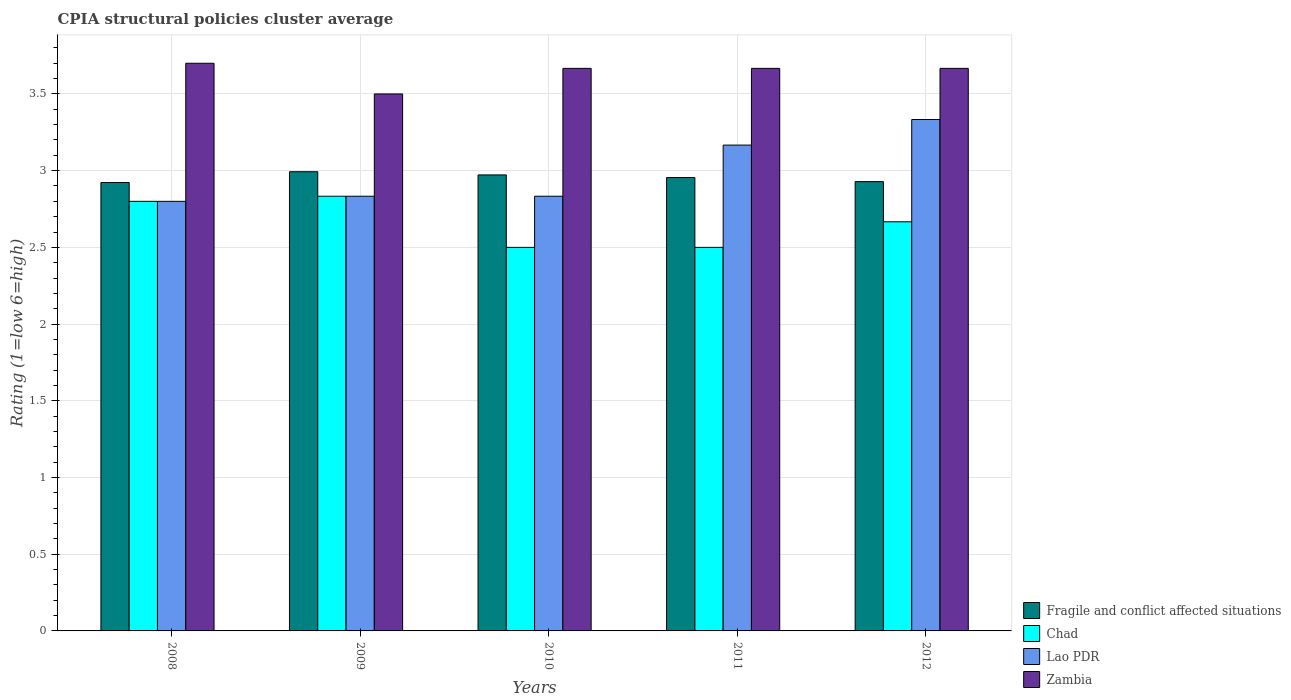How many groups of bars are there?
Make the answer very short. 5. Are the number of bars on each tick of the X-axis equal?
Ensure brevity in your answer.  Yes. What is the label of the 3rd group of bars from the left?
Provide a short and direct response. 2010. Across all years, what is the minimum CPIA rating in Fragile and conflict affected situations?
Ensure brevity in your answer.  2.92. In which year was the CPIA rating in Fragile and conflict affected situations minimum?
Make the answer very short. 2008. What is the total CPIA rating in Zambia in the graph?
Provide a succinct answer. 18.2. What is the difference between the CPIA rating in Lao PDR in 2009 and that in 2010?
Your answer should be compact. 0. What is the difference between the CPIA rating in Lao PDR in 2009 and the CPIA rating in Fragile and conflict affected situations in 2012?
Keep it short and to the point. -0.1. What is the average CPIA rating in Zambia per year?
Give a very brief answer. 3.64. In the year 2009, what is the difference between the CPIA rating in Zambia and CPIA rating in Chad?
Ensure brevity in your answer.  0.67. What is the ratio of the CPIA rating in Zambia in 2008 to that in 2009?
Your response must be concise. 1.06. What is the difference between the highest and the second highest CPIA rating in Fragile and conflict affected situations?
Offer a terse response. 0.02. What is the difference between the highest and the lowest CPIA rating in Zambia?
Provide a succinct answer. 0.2. In how many years, is the CPIA rating in Fragile and conflict affected situations greater than the average CPIA rating in Fragile and conflict affected situations taken over all years?
Ensure brevity in your answer.  3. What does the 3rd bar from the left in 2012 represents?
Your response must be concise. Lao PDR. What does the 1st bar from the right in 2012 represents?
Offer a terse response. Zambia. Is it the case that in every year, the sum of the CPIA rating in Chad and CPIA rating in Zambia is greater than the CPIA rating in Fragile and conflict affected situations?
Make the answer very short. Yes. How many bars are there?
Offer a terse response. 20. Are all the bars in the graph horizontal?
Offer a terse response. No. Does the graph contain any zero values?
Provide a succinct answer. No. Where does the legend appear in the graph?
Provide a short and direct response. Bottom right. How many legend labels are there?
Give a very brief answer. 4. What is the title of the graph?
Provide a succinct answer. CPIA structural policies cluster average. Does "Hong Kong" appear as one of the legend labels in the graph?
Ensure brevity in your answer.  No. What is the label or title of the X-axis?
Your response must be concise. Years. What is the label or title of the Y-axis?
Give a very brief answer. Rating (1=low 6=high). What is the Rating (1=low 6=high) of Fragile and conflict affected situations in 2008?
Your response must be concise. 2.92. What is the Rating (1=low 6=high) in Lao PDR in 2008?
Keep it short and to the point. 2.8. What is the Rating (1=low 6=high) in Zambia in 2008?
Make the answer very short. 3.7. What is the Rating (1=low 6=high) in Fragile and conflict affected situations in 2009?
Your response must be concise. 2.99. What is the Rating (1=low 6=high) of Chad in 2009?
Your response must be concise. 2.83. What is the Rating (1=low 6=high) of Lao PDR in 2009?
Offer a terse response. 2.83. What is the Rating (1=low 6=high) in Fragile and conflict affected situations in 2010?
Your response must be concise. 2.97. What is the Rating (1=low 6=high) in Chad in 2010?
Offer a terse response. 2.5. What is the Rating (1=low 6=high) in Lao PDR in 2010?
Make the answer very short. 2.83. What is the Rating (1=low 6=high) of Zambia in 2010?
Give a very brief answer. 3.67. What is the Rating (1=low 6=high) in Fragile and conflict affected situations in 2011?
Keep it short and to the point. 2.96. What is the Rating (1=low 6=high) in Chad in 2011?
Your answer should be compact. 2.5. What is the Rating (1=low 6=high) of Lao PDR in 2011?
Keep it short and to the point. 3.17. What is the Rating (1=low 6=high) in Zambia in 2011?
Offer a very short reply. 3.67. What is the Rating (1=low 6=high) in Fragile and conflict affected situations in 2012?
Ensure brevity in your answer.  2.93. What is the Rating (1=low 6=high) of Chad in 2012?
Offer a very short reply. 2.67. What is the Rating (1=low 6=high) in Lao PDR in 2012?
Offer a very short reply. 3.33. What is the Rating (1=low 6=high) in Zambia in 2012?
Offer a very short reply. 3.67. Across all years, what is the maximum Rating (1=low 6=high) of Fragile and conflict affected situations?
Provide a short and direct response. 2.99. Across all years, what is the maximum Rating (1=low 6=high) of Chad?
Your answer should be compact. 2.83. Across all years, what is the maximum Rating (1=low 6=high) of Lao PDR?
Offer a very short reply. 3.33. Across all years, what is the minimum Rating (1=low 6=high) in Fragile and conflict affected situations?
Ensure brevity in your answer.  2.92. Across all years, what is the minimum Rating (1=low 6=high) of Lao PDR?
Make the answer very short. 2.8. Across all years, what is the minimum Rating (1=low 6=high) of Zambia?
Provide a succinct answer. 3.5. What is the total Rating (1=low 6=high) of Fragile and conflict affected situations in the graph?
Give a very brief answer. 14.77. What is the total Rating (1=low 6=high) in Lao PDR in the graph?
Give a very brief answer. 14.97. What is the difference between the Rating (1=low 6=high) of Fragile and conflict affected situations in 2008 and that in 2009?
Ensure brevity in your answer.  -0.07. What is the difference between the Rating (1=low 6=high) in Chad in 2008 and that in 2009?
Make the answer very short. -0.03. What is the difference between the Rating (1=low 6=high) of Lao PDR in 2008 and that in 2009?
Ensure brevity in your answer.  -0.03. What is the difference between the Rating (1=low 6=high) of Fragile and conflict affected situations in 2008 and that in 2010?
Keep it short and to the point. -0.05. What is the difference between the Rating (1=low 6=high) in Lao PDR in 2008 and that in 2010?
Your response must be concise. -0.03. What is the difference between the Rating (1=low 6=high) of Fragile and conflict affected situations in 2008 and that in 2011?
Provide a succinct answer. -0.03. What is the difference between the Rating (1=low 6=high) of Chad in 2008 and that in 2011?
Provide a short and direct response. 0.3. What is the difference between the Rating (1=low 6=high) in Lao PDR in 2008 and that in 2011?
Provide a short and direct response. -0.37. What is the difference between the Rating (1=low 6=high) in Fragile and conflict affected situations in 2008 and that in 2012?
Your answer should be very brief. -0.01. What is the difference between the Rating (1=low 6=high) in Chad in 2008 and that in 2012?
Offer a terse response. 0.13. What is the difference between the Rating (1=low 6=high) in Lao PDR in 2008 and that in 2012?
Provide a short and direct response. -0.53. What is the difference between the Rating (1=low 6=high) in Fragile and conflict affected situations in 2009 and that in 2010?
Give a very brief answer. 0.02. What is the difference between the Rating (1=low 6=high) in Zambia in 2009 and that in 2010?
Offer a terse response. -0.17. What is the difference between the Rating (1=low 6=high) in Fragile and conflict affected situations in 2009 and that in 2011?
Make the answer very short. 0.04. What is the difference between the Rating (1=low 6=high) in Fragile and conflict affected situations in 2009 and that in 2012?
Your answer should be compact. 0.06. What is the difference between the Rating (1=low 6=high) in Chad in 2009 and that in 2012?
Offer a very short reply. 0.17. What is the difference between the Rating (1=low 6=high) in Zambia in 2009 and that in 2012?
Provide a succinct answer. -0.17. What is the difference between the Rating (1=low 6=high) of Fragile and conflict affected situations in 2010 and that in 2011?
Your answer should be compact. 0.02. What is the difference between the Rating (1=low 6=high) of Chad in 2010 and that in 2011?
Your answer should be compact. 0. What is the difference between the Rating (1=low 6=high) of Lao PDR in 2010 and that in 2011?
Offer a terse response. -0.33. What is the difference between the Rating (1=low 6=high) in Fragile and conflict affected situations in 2010 and that in 2012?
Keep it short and to the point. 0.04. What is the difference between the Rating (1=low 6=high) in Chad in 2010 and that in 2012?
Offer a terse response. -0.17. What is the difference between the Rating (1=low 6=high) of Zambia in 2010 and that in 2012?
Offer a terse response. 0. What is the difference between the Rating (1=low 6=high) of Fragile and conflict affected situations in 2011 and that in 2012?
Your response must be concise. 0.03. What is the difference between the Rating (1=low 6=high) of Chad in 2011 and that in 2012?
Offer a terse response. -0.17. What is the difference between the Rating (1=low 6=high) of Zambia in 2011 and that in 2012?
Offer a very short reply. 0. What is the difference between the Rating (1=low 6=high) in Fragile and conflict affected situations in 2008 and the Rating (1=low 6=high) in Chad in 2009?
Your answer should be very brief. 0.09. What is the difference between the Rating (1=low 6=high) in Fragile and conflict affected situations in 2008 and the Rating (1=low 6=high) in Lao PDR in 2009?
Give a very brief answer. 0.09. What is the difference between the Rating (1=low 6=high) of Fragile and conflict affected situations in 2008 and the Rating (1=low 6=high) of Zambia in 2009?
Provide a succinct answer. -0.58. What is the difference between the Rating (1=low 6=high) of Chad in 2008 and the Rating (1=low 6=high) of Lao PDR in 2009?
Keep it short and to the point. -0.03. What is the difference between the Rating (1=low 6=high) of Chad in 2008 and the Rating (1=low 6=high) of Zambia in 2009?
Your answer should be compact. -0.7. What is the difference between the Rating (1=low 6=high) of Lao PDR in 2008 and the Rating (1=low 6=high) of Zambia in 2009?
Your answer should be compact. -0.7. What is the difference between the Rating (1=low 6=high) in Fragile and conflict affected situations in 2008 and the Rating (1=low 6=high) in Chad in 2010?
Ensure brevity in your answer.  0.42. What is the difference between the Rating (1=low 6=high) of Fragile and conflict affected situations in 2008 and the Rating (1=low 6=high) of Lao PDR in 2010?
Offer a terse response. 0.09. What is the difference between the Rating (1=low 6=high) in Fragile and conflict affected situations in 2008 and the Rating (1=low 6=high) in Zambia in 2010?
Provide a succinct answer. -0.74. What is the difference between the Rating (1=low 6=high) in Chad in 2008 and the Rating (1=low 6=high) in Lao PDR in 2010?
Make the answer very short. -0.03. What is the difference between the Rating (1=low 6=high) in Chad in 2008 and the Rating (1=low 6=high) in Zambia in 2010?
Keep it short and to the point. -0.87. What is the difference between the Rating (1=low 6=high) in Lao PDR in 2008 and the Rating (1=low 6=high) in Zambia in 2010?
Provide a succinct answer. -0.87. What is the difference between the Rating (1=low 6=high) of Fragile and conflict affected situations in 2008 and the Rating (1=low 6=high) of Chad in 2011?
Ensure brevity in your answer.  0.42. What is the difference between the Rating (1=low 6=high) of Fragile and conflict affected situations in 2008 and the Rating (1=low 6=high) of Lao PDR in 2011?
Ensure brevity in your answer.  -0.24. What is the difference between the Rating (1=low 6=high) in Fragile and conflict affected situations in 2008 and the Rating (1=low 6=high) in Zambia in 2011?
Offer a very short reply. -0.74. What is the difference between the Rating (1=low 6=high) in Chad in 2008 and the Rating (1=low 6=high) in Lao PDR in 2011?
Your answer should be very brief. -0.37. What is the difference between the Rating (1=low 6=high) of Chad in 2008 and the Rating (1=low 6=high) of Zambia in 2011?
Your answer should be compact. -0.87. What is the difference between the Rating (1=low 6=high) of Lao PDR in 2008 and the Rating (1=low 6=high) of Zambia in 2011?
Your answer should be compact. -0.87. What is the difference between the Rating (1=low 6=high) in Fragile and conflict affected situations in 2008 and the Rating (1=low 6=high) in Chad in 2012?
Keep it short and to the point. 0.26. What is the difference between the Rating (1=low 6=high) in Fragile and conflict affected situations in 2008 and the Rating (1=low 6=high) in Lao PDR in 2012?
Provide a short and direct response. -0.41. What is the difference between the Rating (1=low 6=high) in Fragile and conflict affected situations in 2008 and the Rating (1=low 6=high) in Zambia in 2012?
Keep it short and to the point. -0.74. What is the difference between the Rating (1=low 6=high) of Chad in 2008 and the Rating (1=low 6=high) of Lao PDR in 2012?
Provide a short and direct response. -0.53. What is the difference between the Rating (1=low 6=high) in Chad in 2008 and the Rating (1=low 6=high) in Zambia in 2012?
Provide a succinct answer. -0.87. What is the difference between the Rating (1=low 6=high) of Lao PDR in 2008 and the Rating (1=low 6=high) of Zambia in 2012?
Ensure brevity in your answer.  -0.87. What is the difference between the Rating (1=low 6=high) of Fragile and conflict affected situations in 2009 and the Rating (1=low 6=high) of Chad in 2010?
Your response must be concise. 0.49. What is the difference between the Rating (1=low 6=high) of Fragile and conflict affected situations in 2009 and the Rating (1=low 6=high) of Lao PDR in 2010?
Provide a short and direct response. 0.16. What is the difference between the Rating (1=low 6=high) in Fragile and conflict affected situations in 2009 and the Rating (1=low 6=high) in Zambia in 2010?
Offer a terse response. -0.67. What is the difference between the Rating (1=low 6=high) in Lao PDR in 2009 and the Rating (1=low 6=high) in Zambia in 2010?
Provide a succinct answer. -0.83. What is the difference between the Rating (1=low 6=high) in Fragile and conflict affected situations in 2009 and the Rating (1=low 6=high) in Chad in 2011?
Provide a succinct answer. 0.49. What is the difference between the Rating (1=low 6=high) of Fragile and conflict affected situations in 2009 and the Rating (1=low 6=high) of Lao PDR in 2011?
Keep it short and to the point. -0.17. What is the difference between the Rating (1=low 6=high) of Fragile and conflict affected situations in 2009 and the Rating (1=low 6=high) of Zambia in 2011?
Your answer should be compact. -0.67. What is the difference between the Rating (1=low 6=high) in Lao PDR in 2009 and the Rating (1=low 6=high) in Zambia in 2011?
Provide a short and direct response. -0.83. What is the difference between the Rating (1=low 6=high) in Fragile and conflict affected situations in 2009 and the Rating (1=low 6=high) in Chad in 2012?
Offer a terse response. 0.33. What is the difference between the Rating (1=low 6=high) in Fragile and conflict affected situations in 2009 and the Rating (1=low 6=high) in Lao PDR in 2012?
Ensure brevity in your answer.  -0.34. What is the difference between the Rating (1=low 6=high) of Fragile and conflict affected situations in 2009 and the Rating (1=low 6=high) of Zambia in 2012?
Provide a succinct answer. -0.67. What is the difference between the Rating (1=low 6=high) of Chad in 2009 and the Rating (1=low 6=high) of Lao PDR in 2012?
Ensure brevity in your answer.  -0.5. What is the difference between the Rating (1=low 6=high) in Chad in 2009 and the Rating (1=low 6=high) in Zambia in 2012?
Your answer should be compact. -0.83. What is the difference between the Rating (1=low 6=high) of Fragile and conflict affected situations in 2010 and the Rating (1=low 6=high) of Chad in 2011?
Your answer should be compact. 0.47. What is the difference between the Rating (1=low 6=high) of Fragile and conflict affected situations in 2010 and the Rating (1=low 6=high) of Lao PDR in 2011?
Give a very brief answer. -0.19. What is the difference between the Rating (1=low 6=high) in Fragile and conflict affected situations in 2010 and the Rating (1=low 6=high) in Zambia in 2011?
Make the answer very short. -0.69. What is the difference between the Rating (1=low 6=high) in Chad in 2010 and the Rating (1=low 6=high) in Lao PDR in 2011?
Your answer should be very brief. -0.67. What is the difference between the Rating (1=low 6=high) of Chad in 2010 and the Rating (1=low 6=high) of Zambia in 2011?
Provide a succinct answer. -1.17. What is the difference between the Rating (1=low 6=high) in Lao PDR in 2010 and the Rating (1=low 6=high) in Zambia in 2011?
Your answer should be compact. -0.83. What is the difference between the Rating (1=low 6=high) of Fragile and conflict affected situations in 2010 and the Rating (1=low 6=high) of Chad in 2012?
Provide a succinct answer. 0.31. What is the difference between the Rating (1=low 6=high) of Fragile and conflict affected situations in 2010 and the Rating (1=low 6=high) of Lao PDR in 2012?
Give a very brief answer. -0.36. What is the difference between the Rating (1=low 6=high) in Fragile and conflict affected situations in 2010 and the Rating (1=low 6=high) in Zambia in 2012?
Your answer should be very brief. -0.69. What is the difference between the Rating (1=low 6=high) in Chad in 2010 and the Rating (1=low 6=high) in Lao PDR in 2012?
Give a very brief answer. -0.83. What is the difference between the Rating (1=low 6=high) of Chad in 2010 and the Rating (1=low 6=high) of Zambia in 2012?
Your answer should be compact. -1.17. What is the difference between the Rating (1=low 6=high) of Lao PDR in 2010 and the Rating (1=low 6=high) of Zambia in 2012?
Provide a short and direct response. -0.83. What is the difference between the Rating (1=low 6=high) in Fragile and conflict affected situations in 2011 and the Rating (1=low 6=high) in Chad in 2012?
Offer a very short reply. 0.29. What is the difference between the Rating (1=low 6=high) of Fragile and conflict affected situations in 2011 and the Rating (1=low 6=high) of Lao PDR in 2012?
Make the answer very short. -0.38. What is the difference between the Rating (1=low 6=high) of Fragile and conflict affected situations in 2011 and the Rating (1=low 6=high) of Zambia in 2012?
Ensure brevity in your answer.  -0.71. What is the difference between the Rating (1=low 6=high) in Chad in 2011 and the Rating (1=low 6=high) in Zambia in 2012?
Your answer should be compact. -1.17. What is the difference between the Rating (1=low 6=high) in Lao PDR in 2011 and the Rating (1=low 6=high) in Zambia in 2012?
Offer a very short reply. -0.5. What is the average Rating (1=low 6=high) of Fragile and conflict affected situations per year?
Your response must be concise. 2.95. What is the average Rating (1=low 6=high) of Chad per year?
Give a very brief answer. 2.66. What is the average Rating (1=low 6=high) of Lao PDR per year?
Offer a terse response. 2.99. What is the average Rating (1=low 6=high) of Zambia per year?
Provide a succinct answer. 3.64. In the year 2008, what is the difference between the Rating (1=low 6=high) in Fragile and conflict affected situations and Rating (1=low 6=high) in Chad?
Your answer should be very brief. 0.12. In the year 2008, what is the difference between the Rating (1=low 6=high) in Fragile and conflict affected situations and Rating (1=low 6=high) in Lao PDR?
Offer a very short reply. 0.12. In the year 2008, what is the difference between the Rating (1=low 6=high) of Fragile and conflict affected situations and Rating (1=low 6=high) of Zambia?
Provide a succinct answer. -0.78. In the year 2009, what is the difference between the Rating (1=low 6=high) of Fragile and conflict affected situations and Rating (1=low 6=high) of Chad?
Provide a succinct answer. 0.16. In the year 2009, what is the difference between the Rating (1=low 6=high) of Fragile and conflict affected situations and Rating (1=low 6=high) of Lao PDR?
Your response must be concise. 0.16. In the year 2009, what is the difference between the Rating (1=low 6=high) of Fragile and conflict affected situations and Rating (1=low 6=high) of Zambia?
Your answer should be compact. -0.51. In the year 2009, what is the difference between the Rating (1=low 6=high) in Chad and Rating (1=low 6=high) in Lao PDR?
Your answer should be very brief. 0. In the year 2009, what is the difference between the Rating (1=low 6=high) of Chad and Rating (1=low 6=high) of Zambia?
Your response must be concise. -0.67. In the year 2010, what is the difference between the Rating (1=low 6=high) of Fragile and conflict affected situations and Rating (1=low 6=high) of Chad?
Offer a terse response. 0.47. In the year 2010, what is the difference between the Rating (1=low 6=high) in Fragile and conflict affected situations and Rating (1=low 6=high) in Lao PDR?
Make the answer very short. 0.14. In the year 2010, what is the difference between the Rating (1=low 6=high) in Fragile and conflict affected situations and Rating (1=low 6=high) in Zambia?
Your answer should be very brief. -0.69. In the year 2010, what is the difference between the Rating (1=low 6=high) of Chad and Rating (1=low 6=high) of Zambia?
Keep it short and to the point. -1.17. In the year 2010, what is the difference between the Rating (1=low 6=high) in Lao PDR and Rating (1=low 6=high) in Zambia?
Your response must be concise. -0.83. In the year 2011, what is the difference between the Rating (1=low 6=high) of Fragile and conflict affected situations and Rating (1=low 6=high) of Chad?
Provide a succinct answer. 0.46. In the year 2011, what is the difference between the Rating (1=low 6=high) in Fragile and conflict affected situations and Rating (1=low 6=high) in Lao PDR?
Offer a terse response. -0.21. In the year 2011, what is the difference between the Rating (1=low 6=high) of Fragile and conflict affected situations and Rating (1=low 6=high) of Zambia?
Offer a very short reply. -0.71. In the year 2011, what is the difference between the Rating (1=low 6=high) in Chad and Rating (1=low 6=high) in Zambia?
Provide a short and direct response. -1.17. In the year 2012, what is the difference between the Rating (1=low 6=high) of Fragile and conflict affected situations and Rating (1=low 6=high) of Chad?
Provide a succinct answer. 0.26. In the year 2012, what is the difference between the Rating (1=low 6=high) in Fragile and conflict affected situations and Rating (1=low 6=high) in Lao PDR?
Your response must be concise. -0.4. In the year 2012, what is the difference between the Rating (1=low 6=high) of Fragile and conflict affected situations and Rating (1=low 6=high) of Zambia?
Your answer should be compact. -0.74. In the year 2012, what is the difference between the Rating (1=low 6=high) in Chad and Rating (1=low 6=high) in Lao PDR?
Your response must be concise. -0.67. In the year 2012, what is the difference between the Rating (1=low 6=high) of Chad and Rating (1=low 6=high) of Zambia?
Provide a short and direct response. -1. In the year 2012, what is the difference between the Rating (1=low 6=high) in Lao PDR and Rating (1=low 6=high) in Zambia?
Your response must be concise. -0.33. What is the ratio of the Rating (1=low 6=high) of Fragile and conflict affected situations in 2008 to that in 2009?
Offer a terse response. 0.98. What is the ratio of the Rating (1=low 6=high) of Chad in 2008 to that in 2009?
Keep it short and to the point. 0.99. What is the ratio of the Rating (1=low 6=high) in Zambia in 2008 to that in 2009?
Give a very brief answer. 1.06. What is the ratio of the Rating (1=low 6=high) of Fragile and conflict affected situations in 2008 to that in 2010?
Your answer should be very brief. 0.98. What is the ratio of the Rating (1=low 6=high) in Chad in 2008 to that in 2010?
Offer a terse response. 1.12. What is the ratio of the Rating (1=low 6=high) in Lao PDR in 2008 to that in 2010?
Make the answer very short. 0.99. What is the ratio of the Rating (1=low 6=high) of Zambia in 2008 to that in 2010?
Ensure brevity in your answer.  1.01. What is the ratio of the Rating (1=low 6=high) of Fragile and conflict affected situations in 2008 to that in 2011?
Offer a terse response. 0.99. What is the ratio of the Rating (1=low 6=high) of Chad in 2008 to that in 2011?
Keep it short and to the point. 1.12. What is the ratio of the Rating (1=low 6=high) in Lao PDR in 2008 to that in 2011?
Your response must be concise. 0.88. What is the ratio of the Rating (1=low 6=high) in Zambia in 2008 to that in 2011?
Ensure brevity in your answer.  1.01. What is the ratio of the Rating (1=low 6=high) of Fragile and conflict affected situations in 2008 to that in 2012?
Your response must be concise. 1. What is the ratio of the Rating (1=low 6=high) of Chad in 2008 to that in 2012?
Your answer should be very brief. 1.05. What is the ratio of the Rating (1=low 6=high) of Lao PDR in 2008 to that in 2012?
Your answer should be very brief. 0.84. What is the ratio of the Rating (1=low 6=high) of Zambia in 2008 to that in 2012?
Keep it short and to the point. 1.01. What is the ratio of the Rating (1=low 6=high) of Fragile and conflict affected situations in 2009 to that in 2010?
Offer a terse response. 1.01. What is the ratio of the Rating (1=low 6=high) of Chad in 2009 to that in 2010?
Ensure brevity in your answer.  1.13. What is the ratio of the Rating (1=low 6=high) in Zambia in 2009 to that in 2010?
Your answer should be compact. 0.95. What is the ratio of the Rating (1=low 6=high) of Fragile and conflict affected situations in 2009 to that in 2011?
Offer a terse response. 1.01. What is the ratio of the Rating (1=low 6=high) of Chad in 2009 to that in 2011?
Ensure brevity in your answer.  1.13. What is the ratio of the Rating (1=low 6=high) of Lao PDR in 2009 to that in 2011?
Your answer should be very brief. 0.89. What is the ratio of the Rating (1=low 6=high) of Zambia in 2009 to that in 2011?
Provide a succinct answer. 0.95. What is the ratio of the Rating (1=low 6=high) of Fragile and conflict affected situations in 2009 to that in 2012?
Give a very brief answer. 1.02. What is the ratio of the Rating (1=low 6=high) in Chad in 2009 to that in 2012?
Keep it short and to the point. 1.06. What is the ratio of the Rating (1=low 6=high) in Zambia in 2009 to that in 2012?
Ensure brevity in your answer.  0.95. What is the ratio of the Rating (1=low 6=high) in Fragile and conflict affected situations in 2010 to that in 2011?
Make the answer very short. 1.01. What is the ratio of the Rating (1=low 6=high) in Chad in 2010 to that in 2011?
Keep it short and to the point. 1. What is the ratio of the Rating (1=low 6=high) in Lao PDR in 2010 to that in 2011?
Offer a very short reply. 0.89. What is the ratio of the Rating (1=low 6=high) of Fragile and conflict affected situations in 2010 to that in 2012?
Provide a succinct answer. 1.01. What is the ratio of the Rating (1=low 6=high) of Fragile and conflict affected situations in 2011 to that in 2012?
Offer a very short reply. 1.01. What is the ratio of the Rating (1=low 6=high) of Chad in 2011 to that in 2012?
Offer a very short reply. 0.94. What is the ratio of the Rating (1=low 6=high) in Lao PDR in 2011 to that in 2012?
Offer a terse response. 0.95. What is the difference between the highest and the second highest Rating (1=low 6=high) in Fragile and conflict affected situations?
Offer a terse response. 0.02. What is the difference between the highest and the lowest Rating (1=low 6=high) of Fragile and conflict affected situations?
Your response must be concise. 0.07. What is the difference between the highest and the lowest Rating (1=low 6=high) of Chad?
Provide a succinct answer. 0.33. What is the difference between the highest and the lowest Rating (1=low 6=high) of Lao PDR?
Provide a short and direct response. 0.53. 